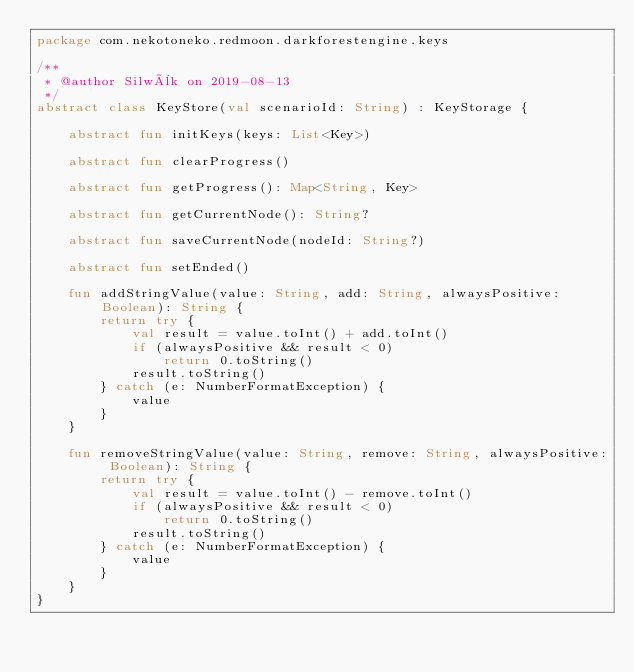<code> <loc_0><loc_0><loc_500><loc_500><_Kotlin_>package com.nekotoneko.redmoon.darkforestengine.keys

/**
 * @author Silwèk on 2019-08-13
 */
abstract class KeyStore(val scenarioId: String) : KeyStorage {

    abstract fun initKeys(keys: List<Key>)

    abstract fun clearProgress()

    abstract fun getProgress(): Map<String, Key>

    abstract fun getCurrentNode(): String?

    abstract fun saveCurrentNode(nodeId: String?)

    abstract fun setEnded()

    fun addStringValue(value: String, add: String, alwaysPositive: Boolean): String {
        return try {
            val result = value.toInt() + add.toInt()
            if (alwaysPositive && result < 0)
                return 0.toString()
            result.toString()
        } catch (e: NumberFormatException) {
            value
        }
    }

    fun removeStringValue(value: String, remove: String, alwaysPositive: Boolean): String {
        return try {
            val result = value.toInt() - remove.toInt()
            if (alwaysPositive && result < 0)
                return 0.toString()
            result.toString()
        } catch (e: NumberFormatException) {
            value
        }
    }
}</code> 